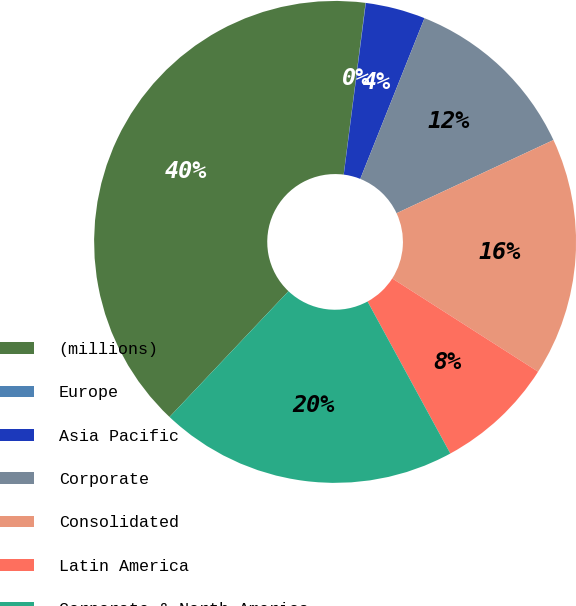<chart> <loc_0><loc_0><loc_500><loc_500><pie_chart><fcel>(millions)<fcel>Europe<fcel>Asia Pacific<fcel>Corporate<fcel>Consolidated<fcel>Latin America<fcel>Corporate & North America<nl><fcel>39.96%<fcel>0.02%<fcel>4.01%<fcel>12.0%<fcel>16.0%<fcel>8.01%<fcel>19.99%<nl></chart> 